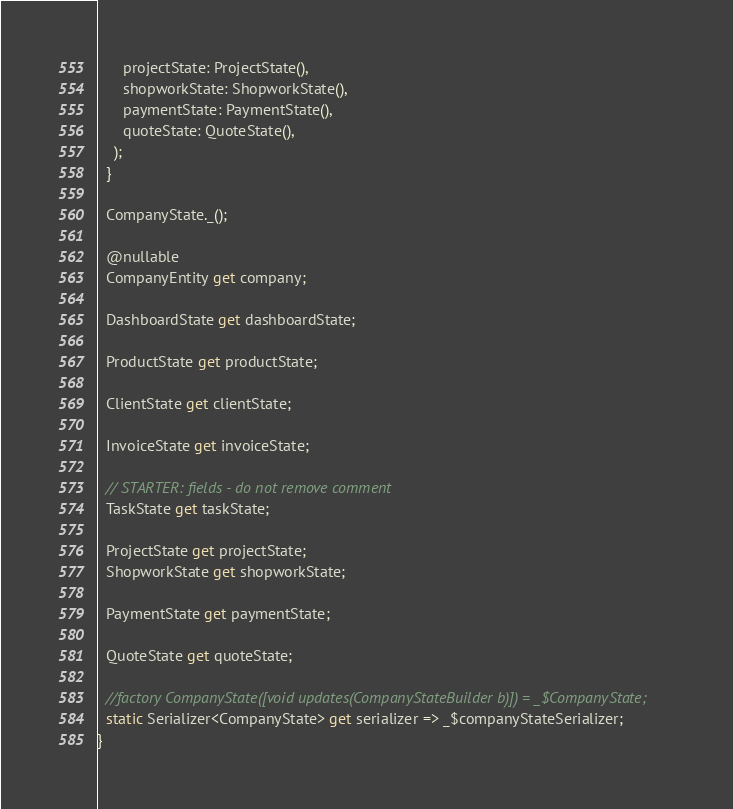<code> <loc_0><loc_0><loc_500><loc_500><_Dart_>      projectState: ProjectState(),
      shopworkState: ShopworkState(),
      paymentState: PaymentState(),
      quoteState: QuoteState(),
    );
  }

  CompanyState._();

  @nullable
  CompanyEntity get company;

  DashboardState get dashboardState;

  ProductState get productState;

  ClientState get clientState;

  InvoiceState get invoiceState;

  // STARTER: fields - do not remove comment
  TaskState get taskState;

  ProjectState get projectState;
  ShopworkState get shopworkState;

  PaymentState get paymentState;

  QuoteState get quoteState;

  //factory CompanyState([void updates(CompanyStateBuilder b)]) = _$CompanyState;
  static Serializer<CompanyState> get serializer => _$companyStateSerializer;
}
</code> 